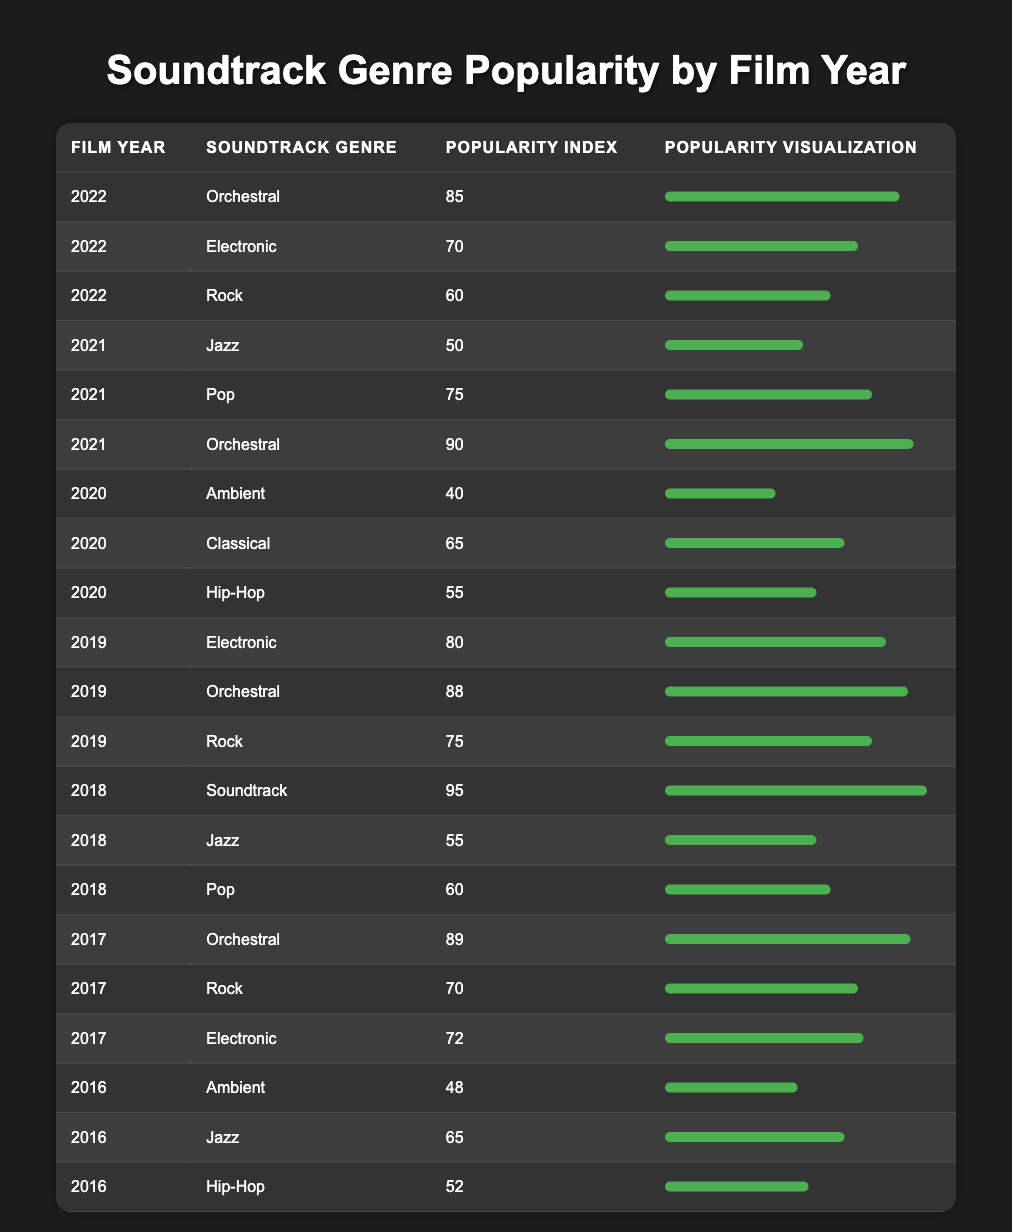What soundtrack genre had the highest popularity in 2022? In 2022, we can look for the maximum value in the Popularity Index column for that year. The popularities for the genres are as follows: Orchestral (85), Electronic (70), and Rock (60). The highest value is for Orchestral.
Answer: Orchestral What is the average Popularity Index for the year 2021? For 2021, the Popularity Indices are: Jazz (50), Pop (75), and Orchestral (90). Adding these values gives us 50 + 75 + 90 = 215. There are 3 entries, so the average is 215 / 3 = 71.67.
Answer: 71.67 Was the popularity of Rock higher in 2019 than in 2021? In 2019, the Popularity Index for Rock is 75, while in 2021 it is 60. We compare the two: 75 > 60, making the statement true.
Answer: Yes Which genre had a popularity index below 50 in 2016? We look at the 2016 entries: Ambient (48), Jazz (65), and Hip-Hop (52). Only Ambient has a Popularity Index below 50.
Answer: Ambient What genre had the least popularity in 2020? In 2020, the Popularity Indices are: Ambient (40), Classical (65), and Hip-Hop (55). The lowest value is for Ambient (40).
Answer: Ambient Was Orchestral music popular in every year listed? Looking at the table, Orchestral has popularity indexes of 85 (2022), 90 (2021), 88 (2019), 95 (2018), 89 (2017), and none for 2020 and 2016. Since there are two years (2020 and 2016) without Orchestral, the genre was not popular in every year.
Answer: No How much more popular was the Jazz genre in 2016 compared to 2021? The Popularity Index for Jazz in 2016 is 65 and in 2021 is 50. The difference is 65 - 50 = 15.
Answer: 15 Which years had Electronic as a soundtrack genre? The years listed with Electronic are 2022 (70), 2017 (72), and 2019 (80).
Answer: 2022, 2017, 2019 